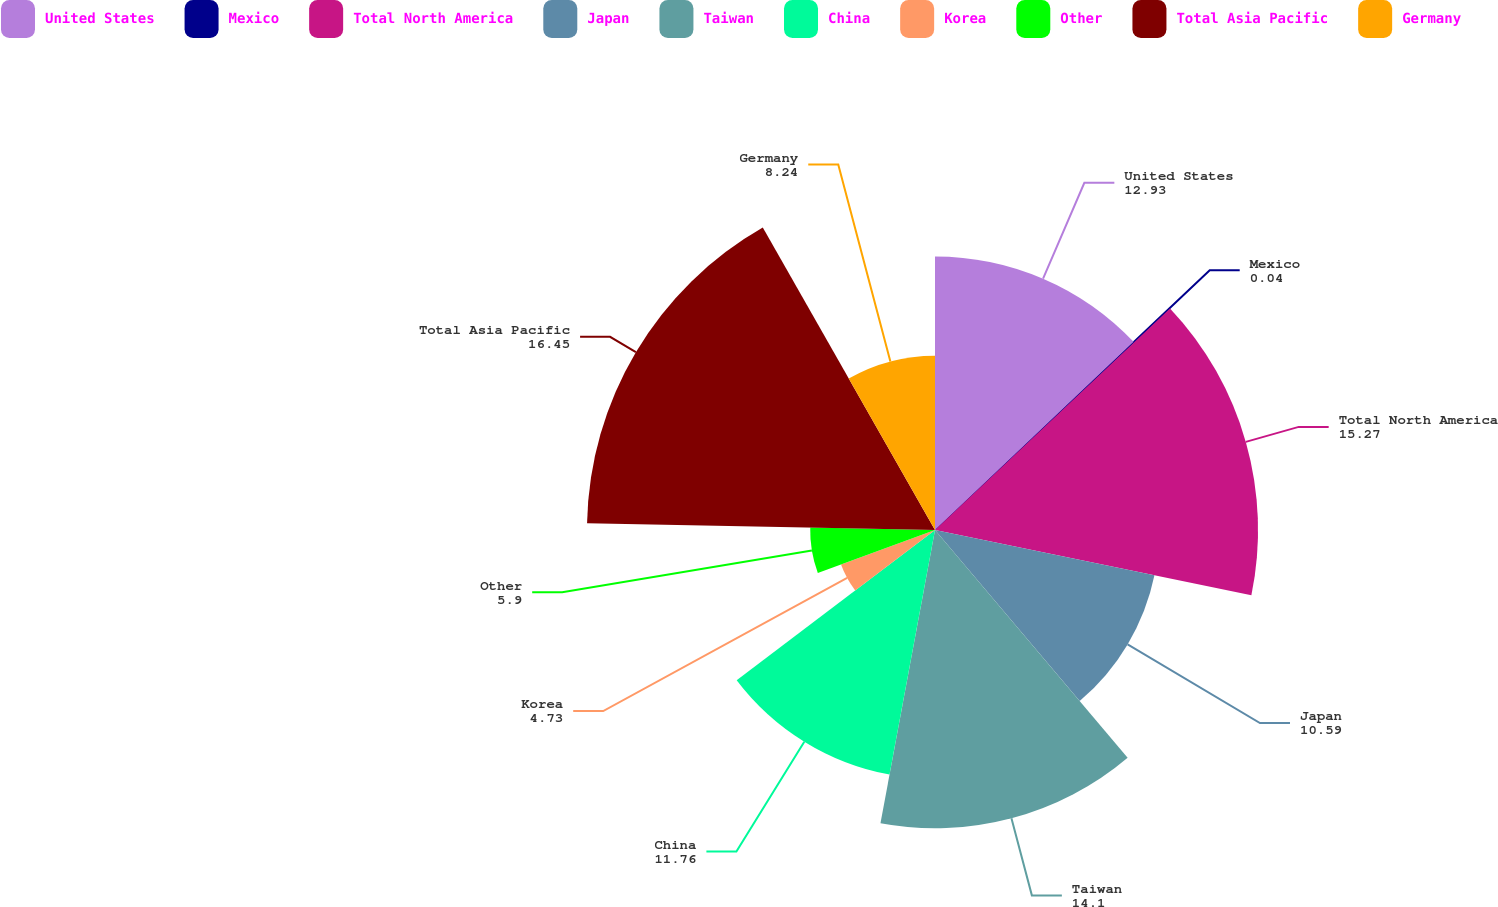Convert chart to OTSL. <chart><loc_0><loc_0><loc_500><loc_500><pie_chart><fcel>United States<fcel>Mexico<fcel>Total North America<fcel>Japan<fcel>Taiwan<fcel>China<fcel>Korea<fcel>Other<fcel>Total Asia Pacific<fcel>Germany<nl><fcel>12.93%<fcel>0.04%<fcel>15.27%<fcel>10.59%<fcel>14.1%<fcel>11.76%<fcel>4.73%<fcel>5.9%<fcel>16.45%<fcel>8.24%<nl></chart> 